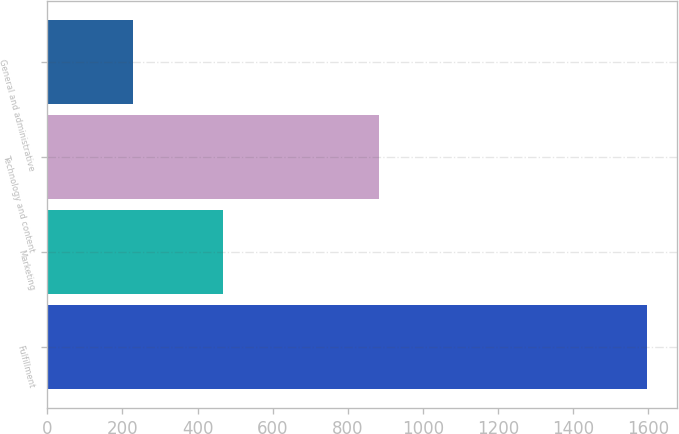Convert chart. <chart><loc_0><loc_0><loc_500><loc_500><bar_chart><fcel>Fulfillment<fcel>Marketing<fcel>Technology and content<fcel>General and administrative<nl><fcel>1597<fcel>469<fcel>882<fcel>229<nl></chart> 